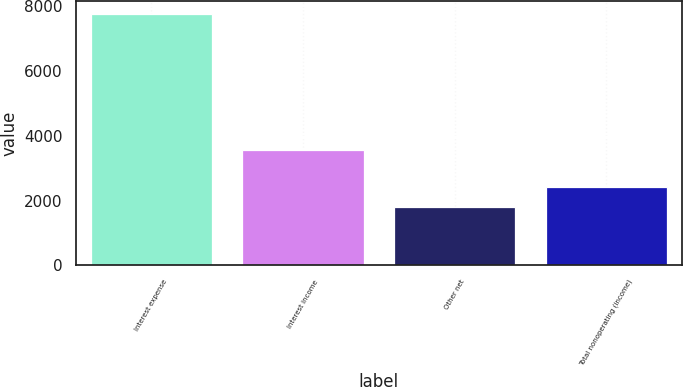<chart> <loc_0><loc_0><loc_500><loc_500><bar_chart><fcel>Interest expense<fcel>Interest income<fcel>Other net<fcel>Total nonoperating (income)<nl><fcel>7754<fcel>3548<fcel>1794<fcel>2412<nl></chart> 